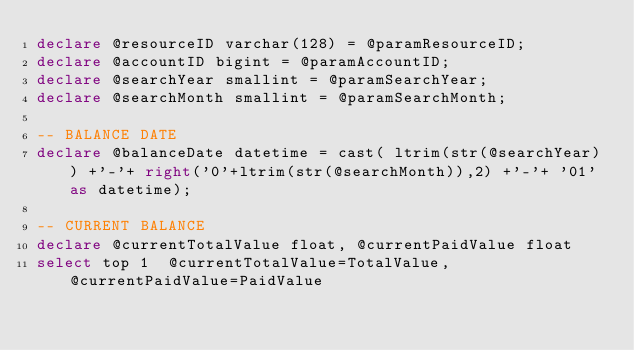<code> <loc_0><loc_0><loc_500><loc_500><_SQL_>declare @resourceID varchar(128) = @paramResourceID;
declare @accountID bigint = @paramAccountID;
declare @searchYear smallint = @paramSearchYear;
declare @searchMonth smallint = @paramSearchMonth;

-- BALANCE DATE
declare @balanceDate datetime = cast( ltrim(str(@searchYear)) +'-'+ right('0'+ltrim(str(@searchMonth)),2) +'-'+ '01' as datetime);

-- CURRENT BALANCE
declare @currentTotalValue float, @currentPaidValue float
select top 1  @currentTotalValue=TotalValue, @currentPaidValue=PaidValue</code> 